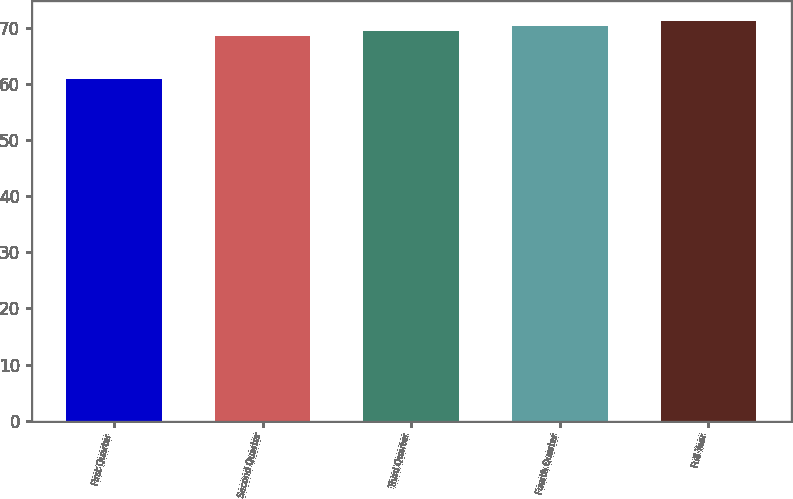Convert chart. <chart><loc_0><loc_0><loc_500><loc_500><bar_chart><fcel>First Quarter<fcel>Second Quarter<fcel>Third Quarter<fcel>Fourth Quarter<fcel>Full Year<nl><fcel>60.96<fcel>68.57<fcel>69.45<fcel>70.33<fcel>71.21<nl></chart> 